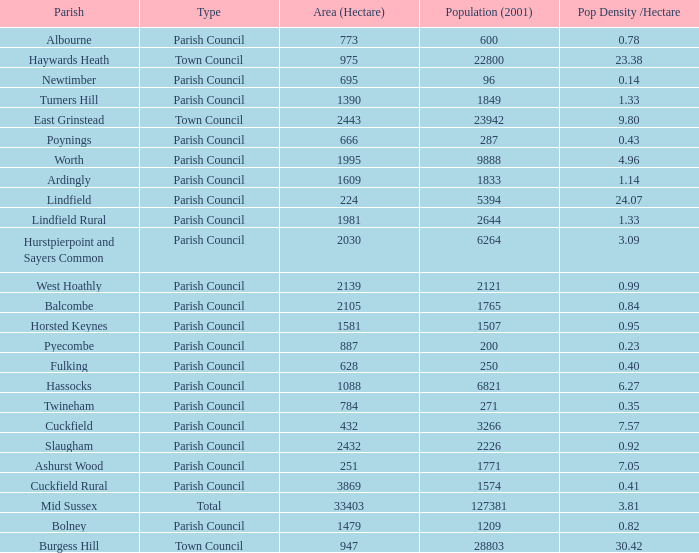What is the area for Worth Parish? 1995.0. 